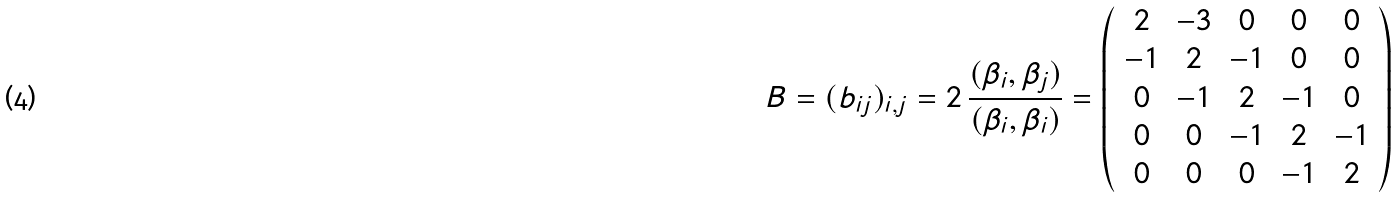Convert formula to latex. <formula><loc_0><loc_0><loc_500><loc_500>B = ( b _ { i j } ) _ { i , j } = 2 \, \frac { ( \beta _ { i } , \beta _ { j } ) } { ( \beta _ { i } , \beta _ { i } ) } = \left ( \begin{array} { c c c c c } 2 & - 3 & 0 & 0 & 0 \\ - 1 & 2 & - 1 & 0 & 0 \\ 0 & - 1 & 2 & - 1 & 0 \\ 0 & 0 & - 1 & 2 & - 1 \\ 0 & 0 & 0 & - 1 & 2 \end{array} \right )</formula> 